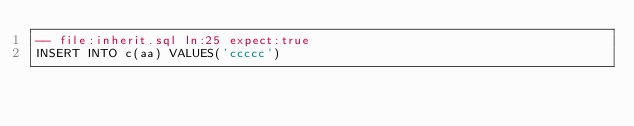Convert code to text. <code><loc_0><loc_0><loc_500><loc_500><_SQL_>-- file:inherit.sql ln:25 expect:true
INSERT INTO c(aa) VALUES('ccccc')
</code> 